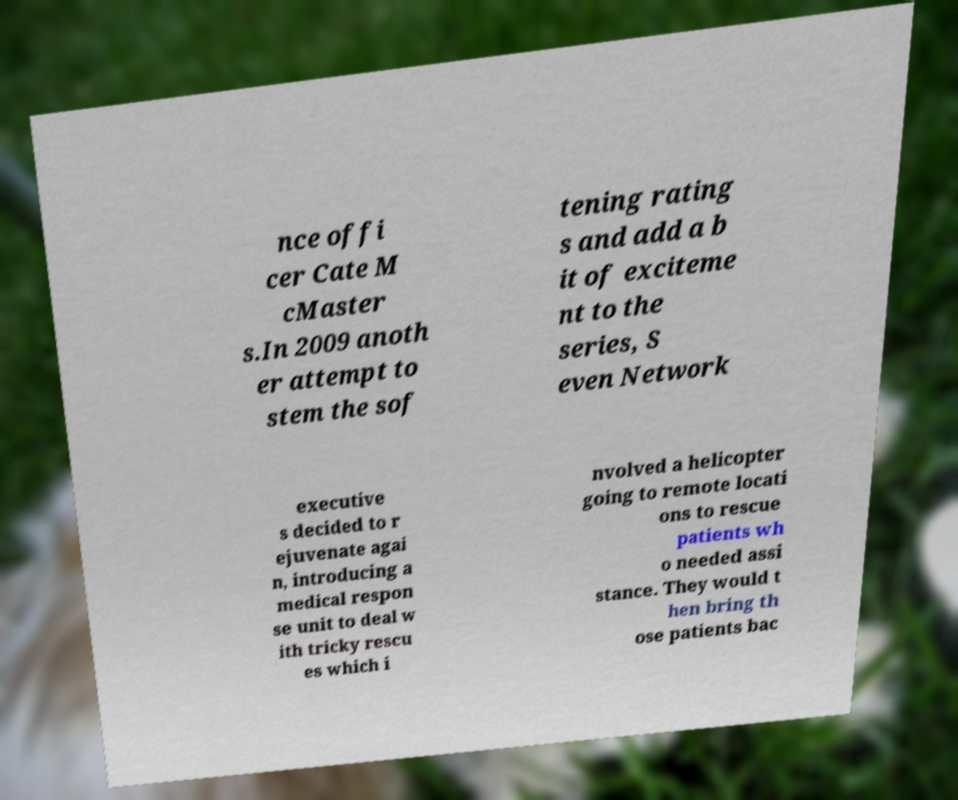There's text embedded in this image that I need extracted. Can you transcribe it verbatim? nce offi cer Cate M cMaster s.In 2009 anoth er attempt to stem the sof tening rating s and add a b it of exciteme nt to the series, S even Network executive s decided to r ejuvenate agai n, introducing a medical respon se unit to deal w ith tricky rescu es which i nvolved a helicopter going to remote locati ons to rescue patients wh o needed assi stance. They would t hen bring th ose patients bac 